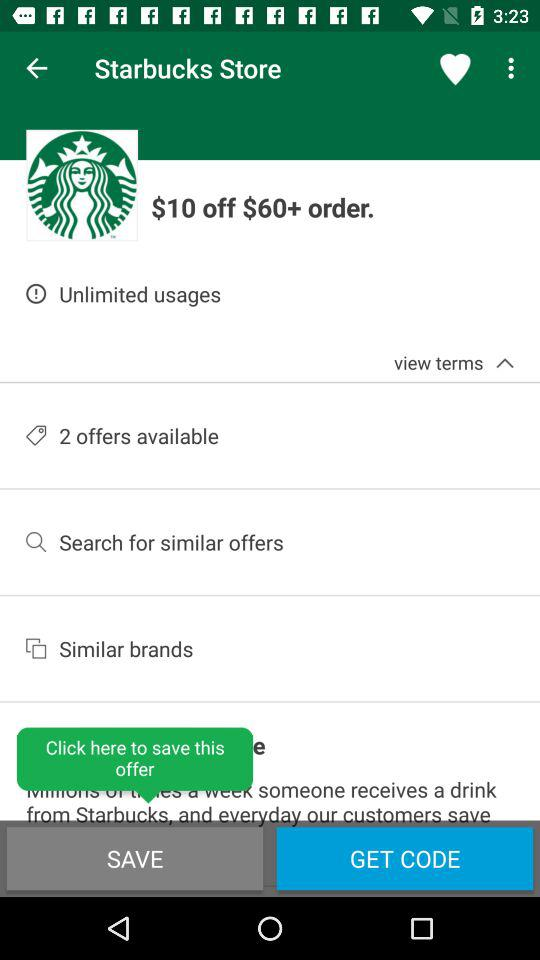How many offers are available?
Answer the question using a single word or phrase. 2 